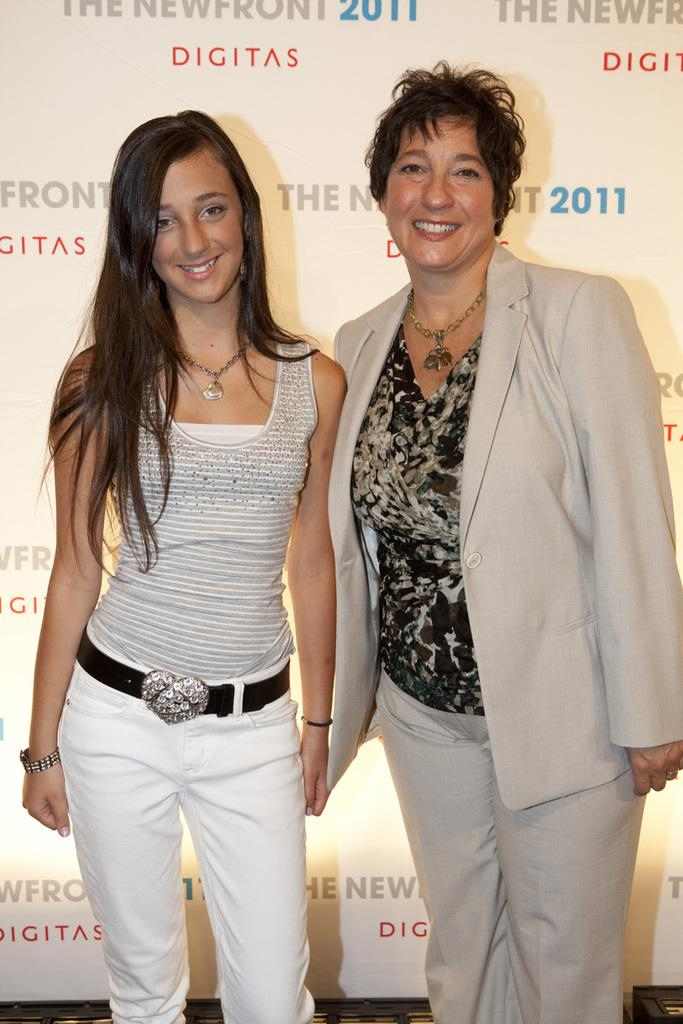How many people are present in the image? There are two women standing in the image. What can be seen in the background of the image? There is a poster in the background of the image. What is featured on the poster? There are brand names on the poster. Are there any tomatoes or celery visible in the image? No, there are no tomatoes or celery present in the image. Can you see a skateboard being used by one of the women in the image? No, there is no skateboard or any indication of skating in the image. 